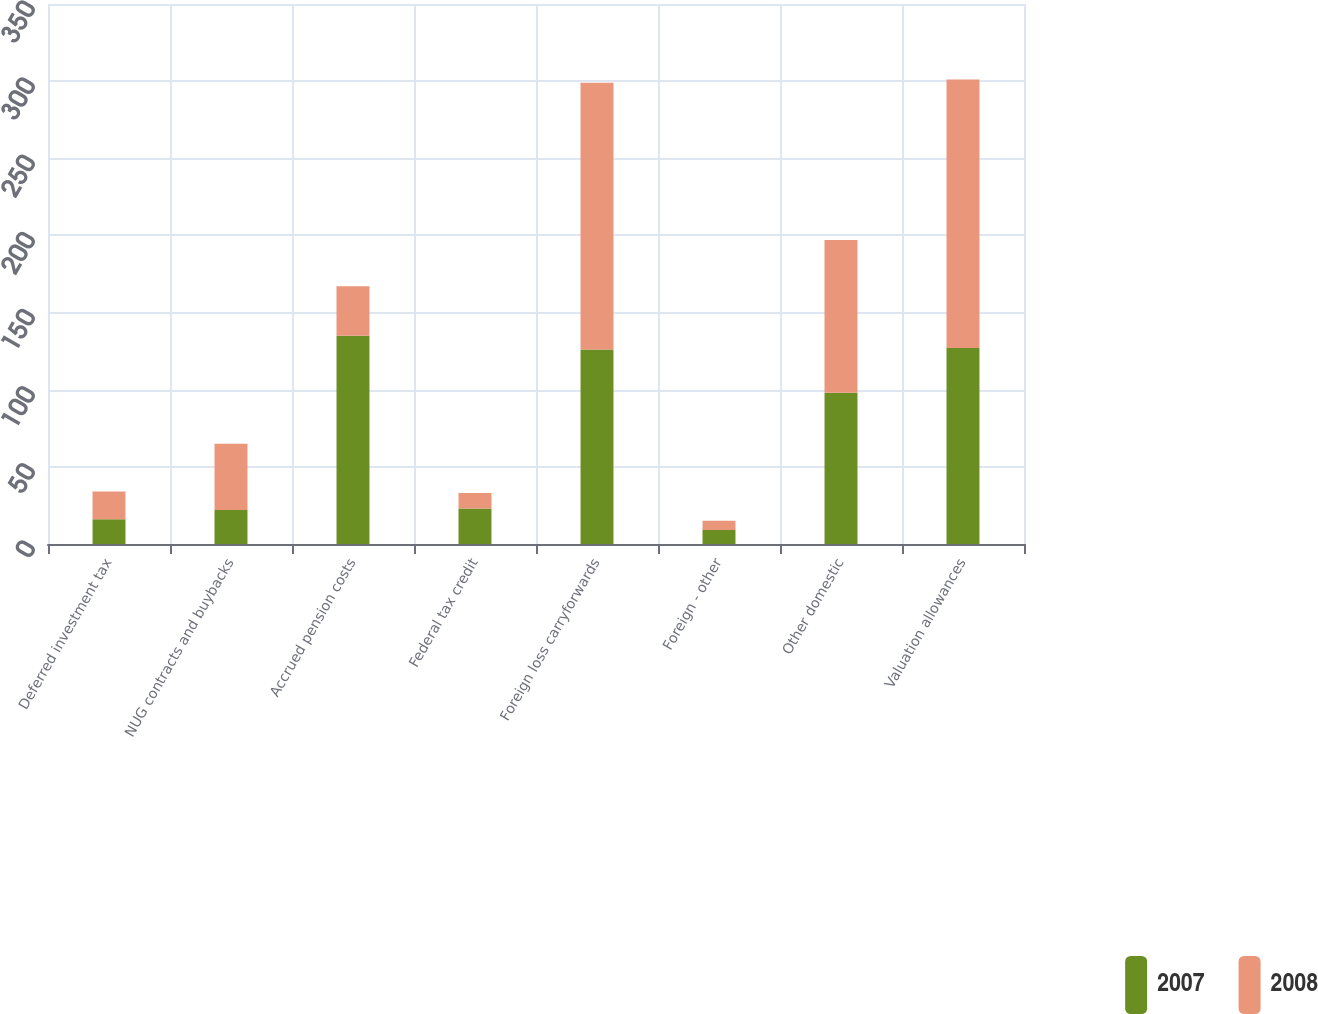<chart> <loc_0><loc_0><loc_500><loc_500><stacked_bar_chart><ecel><fcel>Deferred investment tax<fcel>NUG contracts and buybacks<fcel>Accrued pension costs<fcel>Federal tax credit<fcel>Foreign loss carryforwards<fcel>Foreign - other<fcel>Other domestic<fcel>Valuation allowances<nl><fcel>2007<fcel>16<fcel>22<fcel>135<fcel>23<fcel>126<fcel>9<fcel>98<fcel>127<nl><fcel>2008<fcel>18<fcel>43<fcel>32<fcel>10<fcel>173<fcel>6<fcel>99<fcel>174<nl></chart> 